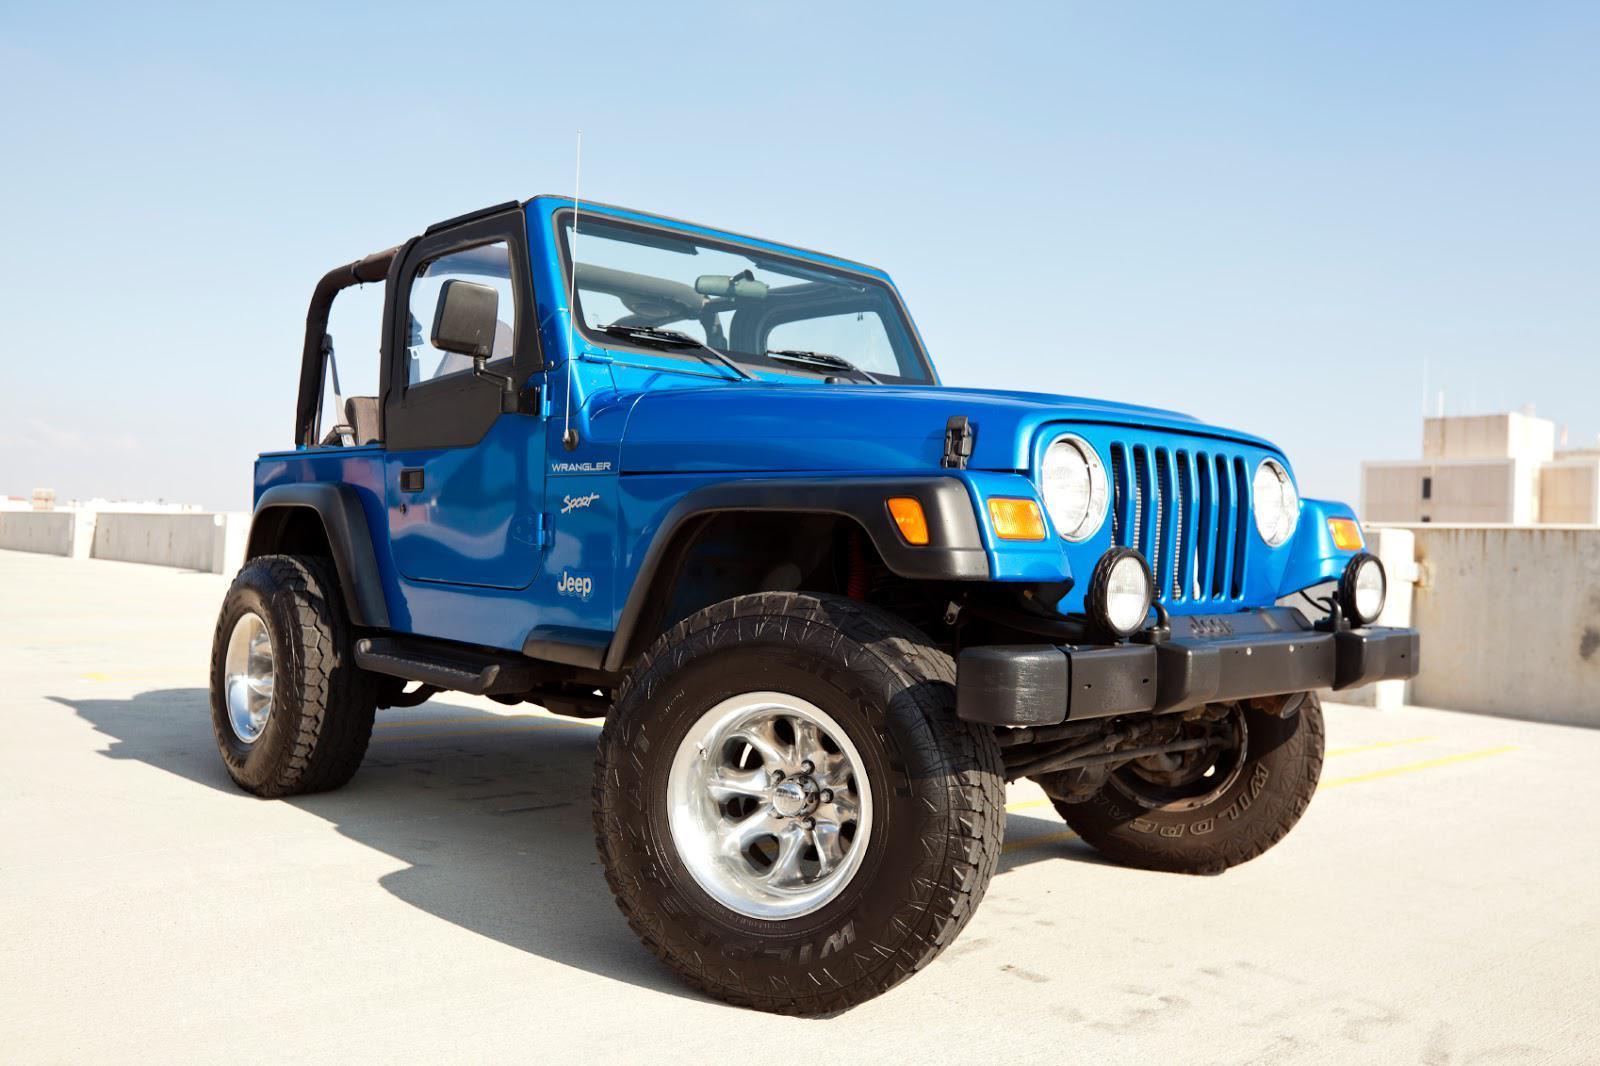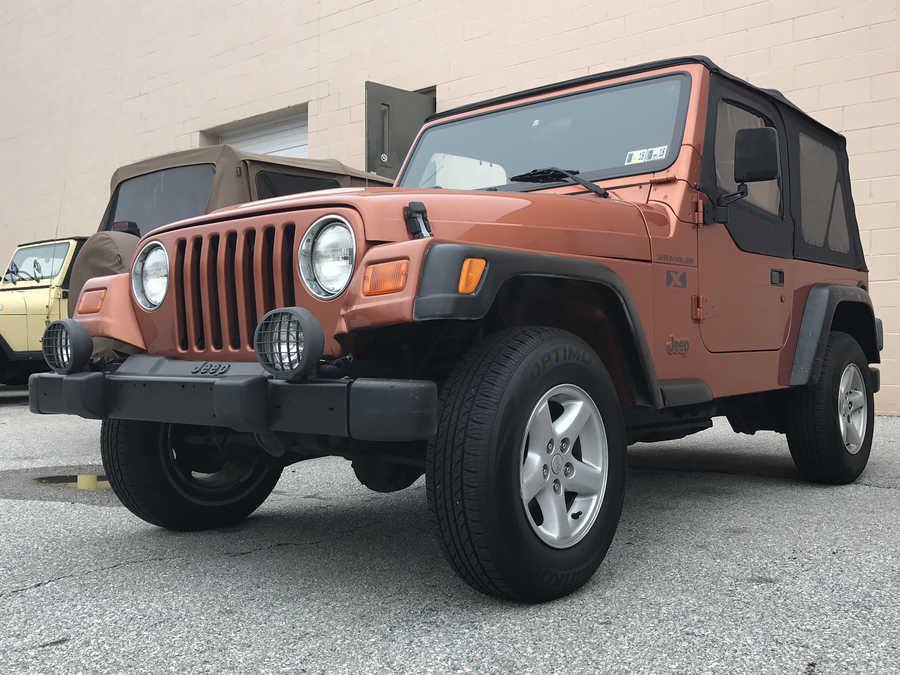The first image is the image on the left, the second image is the image on the right. Assess this claim about the two images: "Both vehicles are Jeep Wranglers.". Correct or not? Answer yes or no. Yes. The first image is the image on the left, the second image is the image on the right. Assess this claim about the two images: "there are two jeeps in the image pair facing each other". Correct or not? Answer yes or no. Yes. 